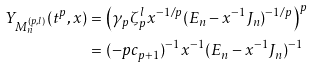<formula> <loc_0><loc_0><loc_500><loc_500>Y _ { M ^ { ( p , l ) } _ { n } } ( t ^ { p } , x ) & = \left ( \gamma _ { p } \zeta _ { p } ^ { l } x ^ { - 1 / p } ( E _ { n } - x ^ { - 1 } J _ { n } ) ^ { - 1 / p } \right ) ^ { p } \\ & = ( - p c _ { p + 1 } ) ^ { - 1 } x ^ { - 1 } ( E _ { n } - x ^ { - 1 } J _ { n } ) ^ { - 1 }</formula> 